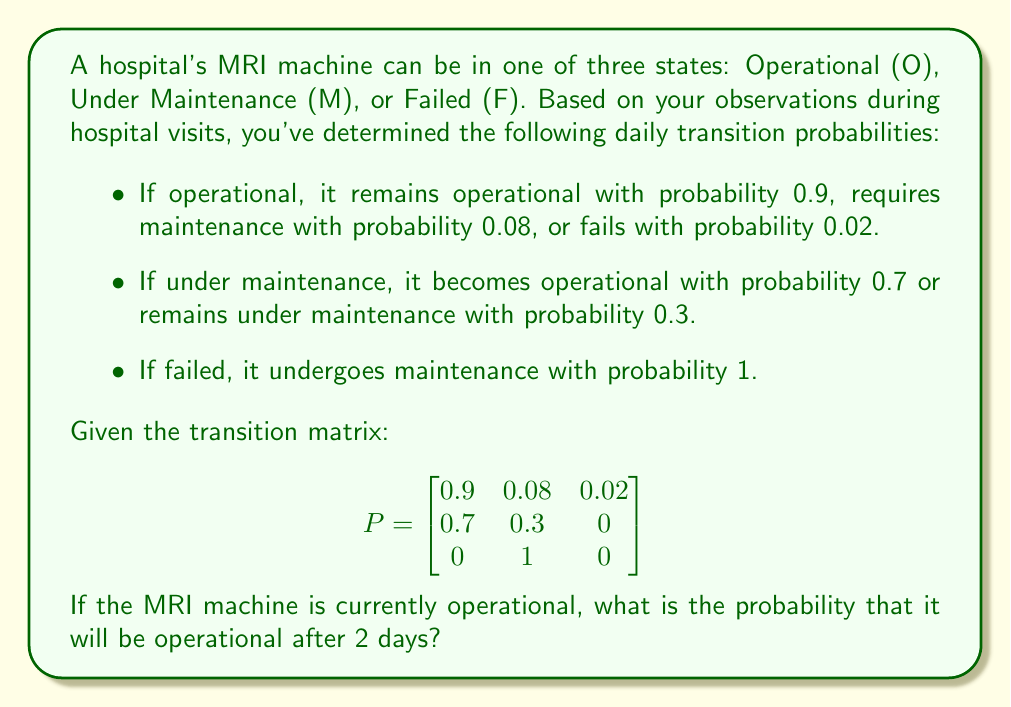What is the answer to this math problem? To solve this problem, we'll use the Markov chain model and matrix multiplication. The steps are as follows:

1) The initial state vector is $v_0 = [1, 0, 0]$ since the machine is currently operational.

2) To find the state after 2 days, we need to multiply the initial state vector by the transition matrix twice:

   $v_2 = v_0 \cdot P^2$

3) Let's calculate $P^2$:

   $$P^2 = P \cdot P = \begin{bmatrix}
   0.9 & 0.08 & 0.02 \\
   0.7 & 0.3 & 0 \\
   0 & 1 & 0
   \end{bmatrix} \cdot \begin{bmatrix}
   0.9 & 0.08 & 0.02 \\
   0.7 & 0.3 & 0 \\
   0 & 1 & 0
   \end{bmatrix}$$

4) Performing the matrix multiplication:

   $$P^2 = \begin{bmatrix}
   0.818 & 0.1562 & 0.0258 \\
   0.84 & 0.146 & 0.014 \\
   0.7 & 0.3 & 0
   \end{bmatrix}$$

5) Now, we multiply the initial state vector by $P^2$:

   $v_2 = [1, 0, 0] \cdot \begin{bmatrix}
   0.818 & 0.1562 & 0.0258 \\
   0.84 & 0.146 & 0.014 \\
   0.7 & 0.3 & 0
   \end{bmatrix}$

6) This gives us:

   $v_2 = [0.818, 0.1562, 0.0258]$

7) The first element of this vector, 0.818, represents the probability that the machine will be operational after 2 days.
Answer: 0.818 